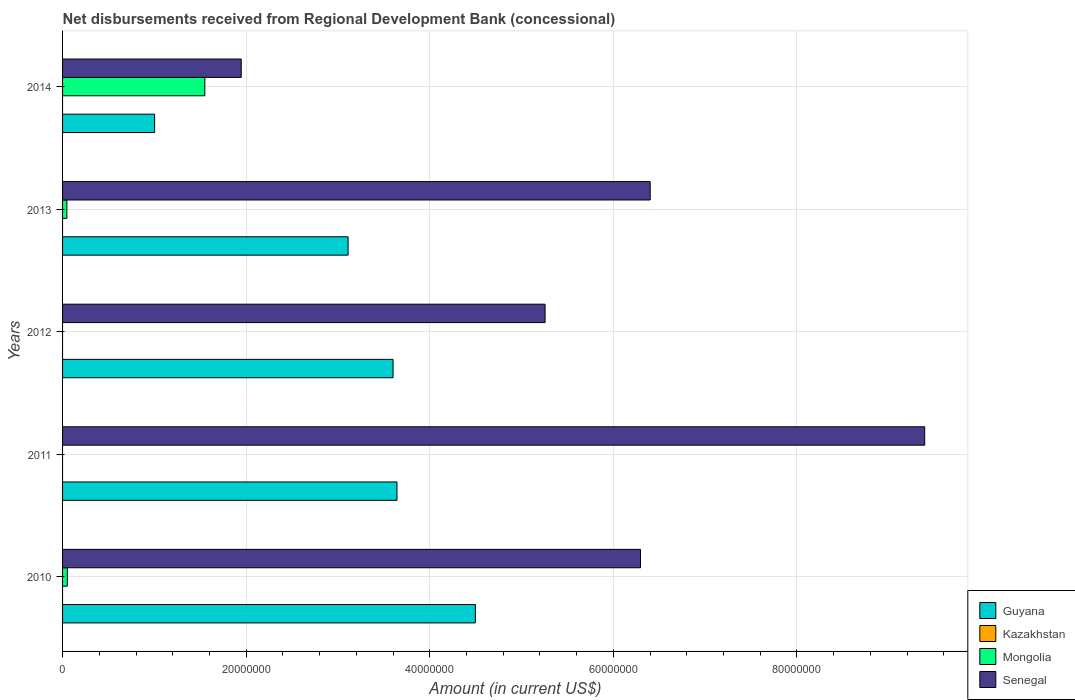How many groups of bars are there?
Ensure brevity in your answer.  5. Are the number of bars on each tick of the Y-axis equal?
Provide a succinct answer. No. How many bars are there on the 5th tick from the top?
Your response must be concise. 3. What is the amount of disbursements received from Regional Development Bank in Mongolia in 2014?
Offer a very short reply. 1.55e+07. Across all years, what is the maximum amount of disbursements received from Regional Development Bank in Senegal?
Offer a very short reply. 9.39e+07. Across all years, what is the minimum amount of disbursements received from Regional Development Bank in Mongolia?
Offer a terse response. 0. In which year was the amount of disbursements received from Regional Development Bank in Senegal maximum?
Offer a very short reply. 2011. What is the total amount of disbursements received from Regional Development Bank in Guyana in the graph?
Make the answer very short. 1.59e+08. What is the difference between the amount of disbursements received from Regional Development Bank in Mongolia in 2010 and that in 2014?
Make the answer very short. -1.50e+07. What is the difference between the amount of disbursements received from Regional Development Bank in Guyana in 2010 and the amount of disbursements received from Regional Development Bank in Senegal in 2014?
Make the answer very short. 2.55e+07. What is the average amount of disbursements received from Regional Development Bank in Guyana per year?
Offer a terse response. 3.17e+07. In the year 2013, what is the difference between the amount of disbursements received from Regional Development Bank in Senegal and amount of disbursements received from Regional Development Bank in Guyana?
Offer a very short reply. 3.29e+07. In how many years, is the amount of disbursements received from Regional Development Bank in Guyana greater than 72000000 US$?
Provide a succinct answer. 0. What is the ratio of the amount of disbursements received from Regional Development Bank in Senegal in 2012 to that in 2013?
Offer a very short reply. 0.82. Is the amount of disbursements received from Regional Development Bank in Guyana in 2010 less than that in 2012?
Offer a very short reply. No. What is the difference between the highest and the second highest amount of disbursements received from Regional Development Bank in Mongolia?
Ensure brevity in your answer.  1.50e+07. What is the difference between the highest and the lowest amount of disbursements received from Regional Development Bank in Guyana?
Your answer should be very brief. 3.49e+07. In how many years, is the amount of disbursements received from Regional Development Bank in Mongolia greater than the average amount of disbursements received from Regional Development Bank in Mongolia taken over all years?
Ensure brevity in your answer.  1. Is the sum of the amount of disbursements received from Regional Development Bank in Guyana in 2012 and 2014 greater than the maximum amount of disbursements received from Regional Development Bank in Senegal across all years?
Your answer should be very brief. No. Is it the case that in every year, the sum of the amount of disbursements received from Regional Development Bank in Kazakhstan and amount of disbursements received from Regional Development Bank in Senegal is greater than the sum of amount of disbursements received from Regional Development Bank in Guyana and amount of disbursements received from Regional Development Bank in Mongolia?
Your response must be concise. No. Is it the case that in every year, the sum of the amount of disbursements received from Regional Development Bank in Mongolia and amount of disbursements received from Regional Development Bank in Guyana is greater than the amount of disbursements received from Regional Development Bank in Senegal?
Offer a very short reply. No. How many bars are there?
Offer a very short reply. 13. Are all the bars in the graph horizontal?
Provide a short and direct response. Yes. What is the difference between two consecutive major ticks on the X-axis?
Your answer should be compact. 2.00e+07. Does the graph contain grids?
Your answer should be very brief. Yes. What is the title of the graph?
Your response must be concise. Net disbursements received from Regional Development Bank (concessional). Does "Greenland" appear as one of the legend labels in the graph?
Your response must be concise. No. What is the Amount (in current US$) in Guyana in 2010?
Your response must be concise. 4.50e+07. What is the Amount (in current US$) in Kazakhstan in 2010?
Your answer should be very brief. 0. What is the Amount (in current US$) in Mongolia in 2010?
Offer a terse response. 5.20e+05. What is the Amount (in current US$) in Senegal in 2010?
Your answer should be very brief. 6.30e+07. What is the Amount (in current US$) in Guyana in 2011?
Your answer should be compact. 3.64e+07. What is the Amount (in current US$) in Kazakhstan in 2011?
Your answer should be very brief. 0. What is the Amount (in current US$) of Mongolia in 2011?
Your answer should be very brief. 0. What is the Amount (in current US$) of Senegal in 2011?
Offer a terse response. 9.39e+07. What is the Amount (in current US$) in Guyana in 2012?
Your response must be concise. 3.60e+07. What is the Amount (in current US$) in Mongolia in 2012?
Provide a short and direct response. 0. What is the Amount (in current US$) in Senegal in 2012?
Your answer should be compact. 5.26e+07. What is the Amount (in current US$) in Guyana in 2013?
Your answer should be compact. 3.11e+07. What is the Amount (in current US$) in Kazakhstan in 2013?
Your response must be concise. 0. What is the Amount (in current US$) in Mongolia in 2013?
Your answer should be compact. 4.69e+05. What is the Amount (in current US$) of Senegal in 2013?
Keep it short and to the point. 6.40e+07. What is the Amount (in current US$) in Guyana in 2014?
Provide a succinct answer. 1.00e+07. What is the Amount (in current US$) of Kazakhstan in 2014?
Provide a succinct answer. 0. What is the Amount (in current US$) of Mongolia in 2014?
Keep it short and to the point. 1.55e+07. What is the Amount (in current US$) of Senegal in 2014?
Make the answer very short. 1.95e+07. Across all years, what is the maximum Amount (in current US$) in Guyana?
Provide a succinct answer. 4.50e+07. Across all years, what is the maximum Amount (in current US$) in Mongolia?
Your answer should be very brief. 1.55e+07. Across all years, what is the maximum Amount (in current US$) in Senegal?
Keep it short and to the point. 9.39e+07. Across all years, what is the minimum Amount (in current US$) in Guyana?
Make the answer very short. 1.00e+07. Across all years, what is the minimum Amount (in current US$) of Mongolia?
Your answer should be very brief. 0. Across all years, what is the minimum Amount (in current US$) of Senegal?
Keep it short and to the point. 1.95e+07. What is the total Amount (in current US$) of Guyana in the graph?
Keep it short and to the point. 1.59e+08. What is the total Amount (in current US$) in Kazakhstan in the graph?
Make the answer very short. 0. What is the total Amount (in current US$) of Mongolia in the graph?
Keep it short and to the point. 1.65e+07. What is the total Amount (in current US$) in Senegal in the graph?
Offer a terse response. 2.93e+08. What is the difference between the Amount (in current US$) in Guyana in 2010 and that in 2011?
Make the answer very short. 8.54e+06. What is the difference between the Amount (in current US$) of Senegal in 2010 and that in 2011?
Your response must be concise. -3.10e+07. What is the difference between the Amount (in current US$) of Guyana in 2010 and that in 2012?
Give a very brief answer. 8.96e+06. What is the difference between the Amount (in current US$) in Senegal in 2010 and that in 2012?
Provide a short and direct response. 1.04e+07. What is the difference between the Amount (in current US$) in Guyana in 2010 and that in 2013?
Your response must be concise. 1.39e+07. What is the difference between the Amount (in current US$) of Mongolia in 2010 and that in 2013?
Your answer should be very brief. 5.10e+04. What is the difference between the Amount (in current US$) in Senegal in 2010 and that in 2013?
Ensure brevity in your answer.  -1.06e+06. What is the difference between the Amount (in current US$) of Guyana in 2010 and that in 2014?
Give a very brief answer. 3.49e+07. What is the difference between the Amount (in current US$) of Mongolia in 2010 and that in 2014?
Keep it short and to the point. -1.50e+07. What is the difference between the Amount (in current US$) in Senegal in 2010 and that in 2014?
Provide a succinct answer. 4.35e+07. What is the difference between the Amount (in current US$) of Guyana in 2011 and that in 2012?
Your answer should be compact. 4.26e+05. What is the difference between the Amount (in current US$) in Senegal in 2011 and that in 2012?
Your answer should be compact. 4.14e+07. What is the difference between the Amount (in current US$) of Guyana in 2011 and that in 2013?
Make the answer very short. 5.32e+06. What is the difference between the Amount (in current US$) of Senegal in 2011 and that in 2013?
Provide a succinct answer. 2.99e+07. What is the difference between the Amount (in current US$) of Guyana in 2011 and that in 2014?
Ensure brevity in your answer.  2.64e+07. What is the difference between the Amount (in current US$) of Senegal in 2011 and that in 2014?
Your answer should be compact. 7.44e+07. What is the difference between the Amount (in current US$) in Guyana in 2012 and that in 2013?
Your answer should be compact. 4.90e+06. What is the difference between the Amount (in current US$) in Senegal in 2012 and that in 2013?
Make the answer very short. -1.15e+07. What is the difference between the Amount (in current US$) in Guyana in 2012 and that in 2014?
Offer a terse response. 2.60e+07. What is the difference between the Amount (in current US$) of Senegal in 2012 and that in 2014?
Offer a very short reply. 3.31e+07. What is the difference between the Amount (in current US$) of Guyana in 2013 and that in 2014?
Give a very brief answer. 2.11e+07. What is the difference between the Amount (in current US$) of Mongolia in 2013 and that in 2014?
Provide a succinct answer. -1.50e+07. What is the difference between the Amount (in current US$) in Senegal in 2013 and that in 2014?
Make the answer very short. 4.45e+07. What is the difference between the Amount (in current US$) in Guyana in 2010 and the Amount (in current US$) in Senegal in 2011?
Make the answer very short. -4.89e+07. What is the difference between the Amount (in current US$) in Mongolia in 2010 and the Amount (in current US$) in Senegal in 2011?
Your answer should be compact. -9.34e+07. What is the difference between the Amount (in current US$) of Guyana in 2010 and the Amount (in current US$) of Senegal in 2012?
Your answer should be compact. -7.59e+06. What is the difference between the Amount (in current US$) of Mongolia in 2010 and the Amount (in current US$) of Senegal in 2012?
Keep it short and to the point. -5.20e+07. What is the difference between the Amount (in current US$) in Guyana in 2010 and the Amount (in current US$) in Mongolia in 2013?
Provide a succinct answer. 4.45e+07. What is the difference between the Amount (in current US$) of Guyana in 2010 and the Amount (in current US$) of Senegal in 2013?
Your answer should be compact. -1.90e+07. What is the difference between the Amount (in current US$) of Mongolia in 2010 and the Amount (in current US$) of Senegal in 2013?
Your response must be concise. -6.35e+07. What is the difference between the Amount (in current US$) of Guyana in 2010 and the Amount (in current US$) of Mongolia in 2014?
Your answer should be compact. 2.95e+07. What is the difference between the Amount (in current US$) of Guyana in 2010 and the Amount (in current US$) of Senegal in 2014?
Ensure brevity in your answer.  2.55e+07. What is the difference between the Amount (in current US$) of Mongolia in 2010 and the Amount (in current US$) of Senegal in 2014?
Offer a very short reply. -1.89e+07. What is the difference between the Amount (in current US$) of Guyana in 2011 and the Amount (in current US$) of Senegal in 2012?
Your response must be concise. -1.61e+07. What is the difference between the Amount (in current US$) of Guyana in 2011 and the Amount (in current US$) of Mongolia in 2013?
Your answer should be very brief. 3.60e+07. What is the difference between the Amount (in current US$) of Guyana in 2011 and the Amount (in current US$) of Senegal in 2013?
Your response must be concise. -2.76e+07. What is the difference between the Amount (in current US$) in Guyana in 2011 and the Amount (in current US$) in Mongolia in 2014?
Ensure brevity in your answer.  2.09e+07. What is the difference between the Amount (in current US$) in Guyana in 2011 and the Amount (in current US$) in Senegal in 2014?
Provide a succinct answer. 1.70e+07. What is the difference between the Amount (in current US$) of Guyana in 2012 and the Amount (in current US$) of Mongolia in 2013?
Provide a succinct answer. 3.55e+07. What is the difference between the Amount (in current US$) of Guyana in 2012 and the Amount (in current US$) of Senegal in 2013?
Your answer should be very brief. -2.80e+07. What is the difference between the Amount (in current US$) of Guyana in 2012 and the Amount (in current US$) of Mongolia in 2014?
Provide a succinct answer. 2.05e+07. What is the difference between the Amount (in current US$) of Guyana in 2012 and the Amount (in current US$) of Senegal in 2014?
Your answer should be very brief. 1.65e+07. What is the difference between the Amount (in current US$) in Guyana in 2013 and the Amount (in current US$) in Mongolia in 2014?
Your answer should be compact. 1.56e+07. What is the difference between the Amount (in current US$) of Guyana in 2013 and the Amount (in current US$) of Senegal in 2014?
Your answer should be compact. 1.16e+07. What is the difference between the Amount (in current US$) of Mongolia in 2013 and the Amount (in current US$) of Senegal in 2014?
Provide a short and direct response. -1.90e+07. What is the average Amount (in current US$) in Guyana per year?
Your answer should be compact. 3.17e+07. What is the average Amount (in current US$) in Mongolia per year?
Your answer should be compact. 3.30e+06. What is the average Amount (in current US$) of Senegal per year?
Make the answer very short. 5.86e+07. In the year 2010, what is the difference between the Amount (in current US$) in Guyana and Amount (in current US$) in Mongolia?
Offer a very short reply. 4.44e+07. In the year 2010, what is the difference between the Amount (in current US$) of Guyana and Amount (in current US$) of Senegal?
Ensure brevity in your answer.  -1.80e+07. In the year 2010, what is the difference between the Amount (in current US$) in Mongolia and Amount (in current US$) in Senegal?
Provide a succinct answer. -6.24e+07. In the year 2011, what is the difference between the Amount (in current US$) of Guyana and Amount (in current US$) of Senegal?
Give a very brief answer. -5.75e+07. In the year 2012, what is the difference between the Amount (in current US$) in Guyana and Amount (in current US$) in Senegal?
Provide a succinct answer. -1.66e+07. In the year 2013, what is the difference between the Amount (in current US$) of Guyana and Amount (in current US$) of Mongolia?
Your answer should be compact. 3.06e+07. In the year 2013, what is the difference between the Amount (in current US$) of Guyana and Amount (in current US$) of Senegal?
Provide a short and direct response. -3.29e+07. In the year 2013, what is the difference between the Amount (in current US$) of Mongolia and Amount (in current US$) of Senegal?
Offer a very short reply. -6.35e+07. In the year 2014, what is the difference between the Amount (in current US$) in Guyana and Amount (in current US$) in Mongolia?
Ensure brevity in your answer.  -5.47e+06. In the year 2014, what is the difference between the Amount (in current US$) in Guyana and Amount (in current US$) in Senegal?
Provide a succinct answer. -9.44e+06. In the year 2014, what is the difference between the Amount (in current US$) of Mongolia and Amount (in current US$) of Senegal?
Give a very brief answer. -3.96e+06. What is the ratio of the Amount (in current US$) in Guyana in 2010 to that in 2011?
Offer a terse response. 1.23. What is the ratio of the Amount (in current US$) of Senegal in 2010 to that in 2011?
Your answer should be very brief. 0.67. What is the ratio of the Amount (in current US$) of Guyana in 2010 to that in 2012?
Offer a terse response. 1.25. What is the ratio of the Amount (in current US$) of Senegal in 2010 to that in 2012?
Your response must be concise. 1.2. What is the ratio of the Amount (in current US$) of Guyana in 2010 to that in 2013?
Your answer should be very brief. 1.45. What is the ratio of the Amount (in current US$) in Mongolia in 2010 to that in 2013?
Provide a short and direct response. 1.11. What is the ratio of the Amount (in current US$) in Senegal in 2010 to that in 2013?
Offer a very short reply. 0.98. What is the ratio of the Amount (in current US$) in Guyana in 2010 to that in 2014?
Provide a succinct answer. 4.48. What is the ratio of the Amount (in current US$) in Mongolia in 2010 to that in 2014?
Your answer should be compact. 0.03. What is the ratio of the Amount (in current US$) in Senegal in 2010 to that in 2014?
Make the answer very short. 3.23. What is the ratio of the Amount (in current US$) in Guyana in 2011 to that in 2012?
Make the answer very short. 1.01. What is the ratio of the Amount (in current US$) in Senegal in 2011 to that in 2012?
Provide a succinct answer. 1.79. What is the ratio of the Amount (in current US$) in Guyana in 2011 to that in 2013?
Your answer should be very brief. 1.17. What is the ratio of the Amount (in current US$) of Senegal in 2011 to that in 2013?
Your response must be concise. 1.47. What is the ratio of the Amount (in current US$) of Guyana in 2011 to that in 2014?
Your response must be concise. 3.63. What is the ratio of the Amount (in current US$) in Senegal in 2011 to that in 2014?
Give a very brief answer. 4.83. What is the ratio of the Amount (in current US$) of Guyana in 2012 to that in 2013?
Your answer should be very brief. 1.16. What is the ratio of the Amount (in current US$) in Senegal in 2012 to that in 2013?
Ensure brevity in your answer.  0.82. What is the ratio of the Amount (in current US$) in Guyana in 2012 to that in 2014?
Your answer should be very brief. 3.59. What is the ratio of the Amount (in current US$) of Senegal in 2012 to that in 2014?
Keep it short and to the point. 2.7. What is the ratio of the Amount (in current US$) of Guyana in 2013 to that in 2014?
Keep it short and to the point. 3.1. What is the ratio of the Amount (in current US$) in Mongolia in 2013 to that in 2014?
Provide a short and direct response. 0.03. What is the ratio of the Amount (in current US$) in Senegal in 2013 to that in 2014?
Your response must be concise. 3.29. What is the difference between the highest and the second highest Amount (in current US$) of Guyana?
Ensure brevity in your answer.  8.54e+06. What is the difference between the highest and the second highest Amount (in current US$) in Mongolia?
Make the answer very short. 1.50e+07. What is the difference between the highest and the second highest Amount (in current US$) of Senegal?
Keep it short and to the point. 2.99e+07. What is the difference between the highest and the lowest Amount (in current US$) of Guyana?
Offer a terse response. 3.49e+07. What is the difference between the highest and the lowest Amount (in current US$) of Mongolia?
Keep it short and to the point. 1.55e+07. What is the difference between the highest and the lowest Amount (in current US$) of Senegal?
Offer a very short reply. 7.44e+07. 